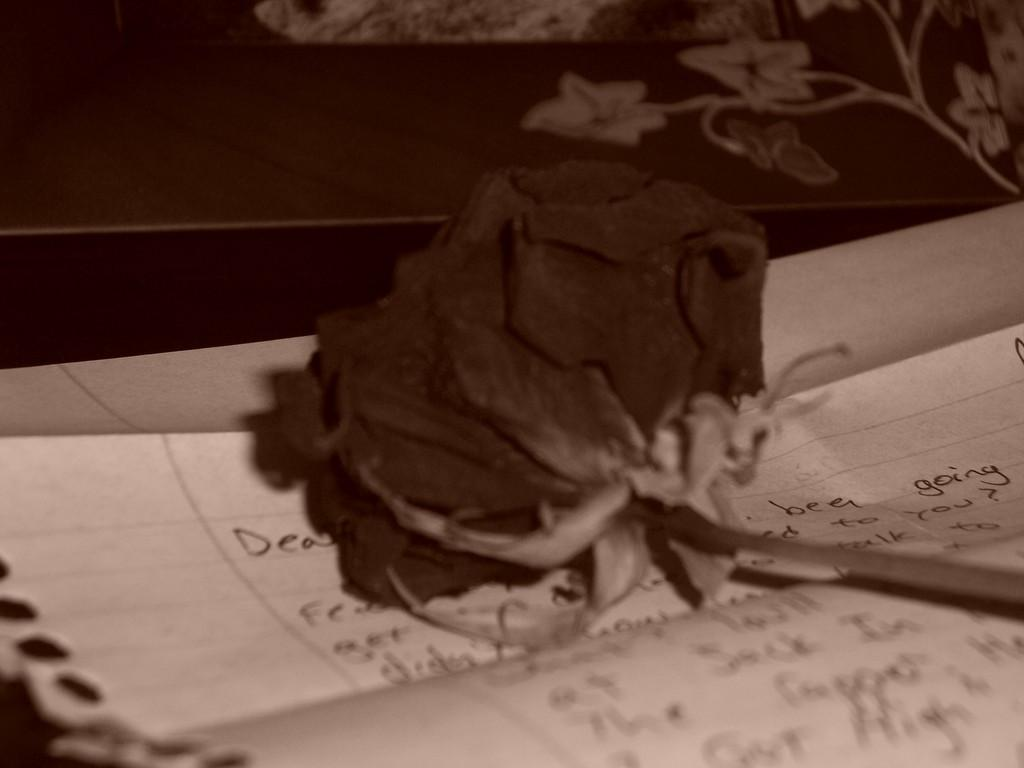What type of furniture is present in the image? There is a table in the image. What is placed on the table? There is a paper and a flower on the table. What is the tongue's role in the image? There is no tongue present in the image. 